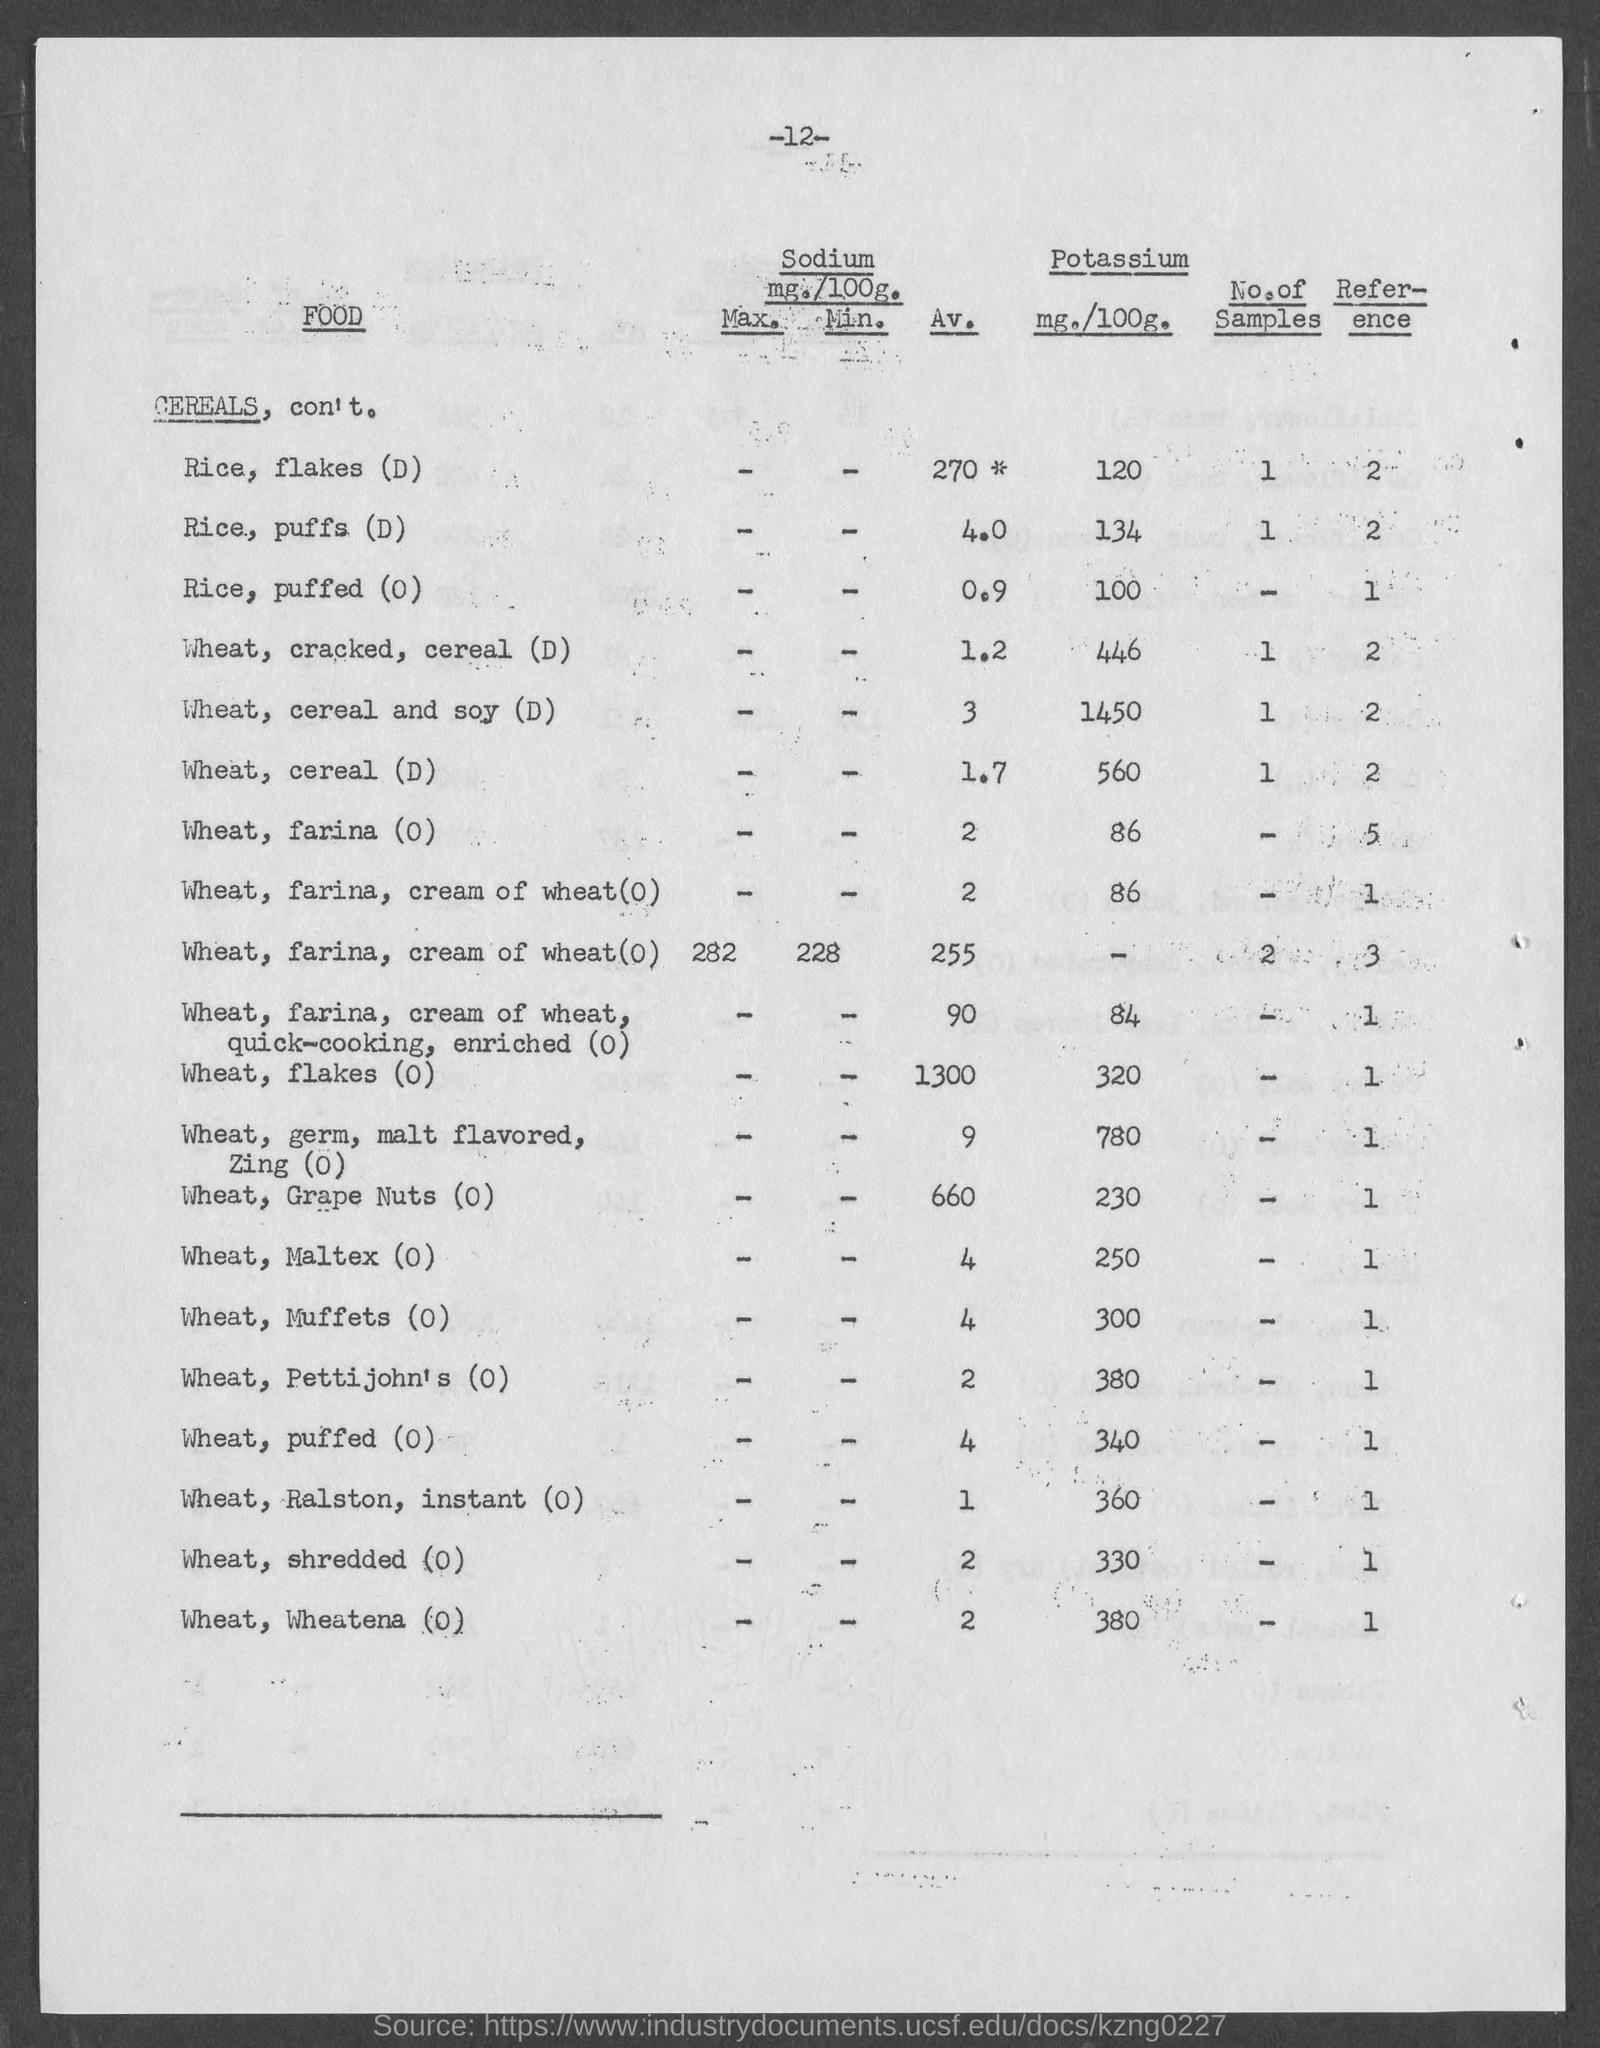What is the number at top of the page ?
Your response must be concise. -12-. What is amount of potassium mg./100g. of rice, flakes (d)?
Your answer should be very brief. 120. What is amount of potassium mg./100g. of ric, puffs (d)?
Make the answer very short. 134. What is amount of potassium mg./100g. of rice, puffed(o) ?
Ensure brevity in your answer.  100. What is amount of potassium mg./100g. of wheat, cracked, cereal (d) ?
Your answer should be very brief. 446. What is amount of potassium mg./100g. of wheat, cereal and soy (d)?
Keep it short and to the point. 1450. What is amount of potassium mg./100g. of wheat, cereal (d)?
Your response must be concise. 560. What is amount of potassium mg./100g. of wheat, farina (o)?
Your answer should be very brief. 86. What is amount of potassium mg./100g. of wheat, maltex (o)?
Give a very brief answer. 250. What is amount of potassium mg./100g. of wheat, muffets (o)?
Your response must be concise. 300. 